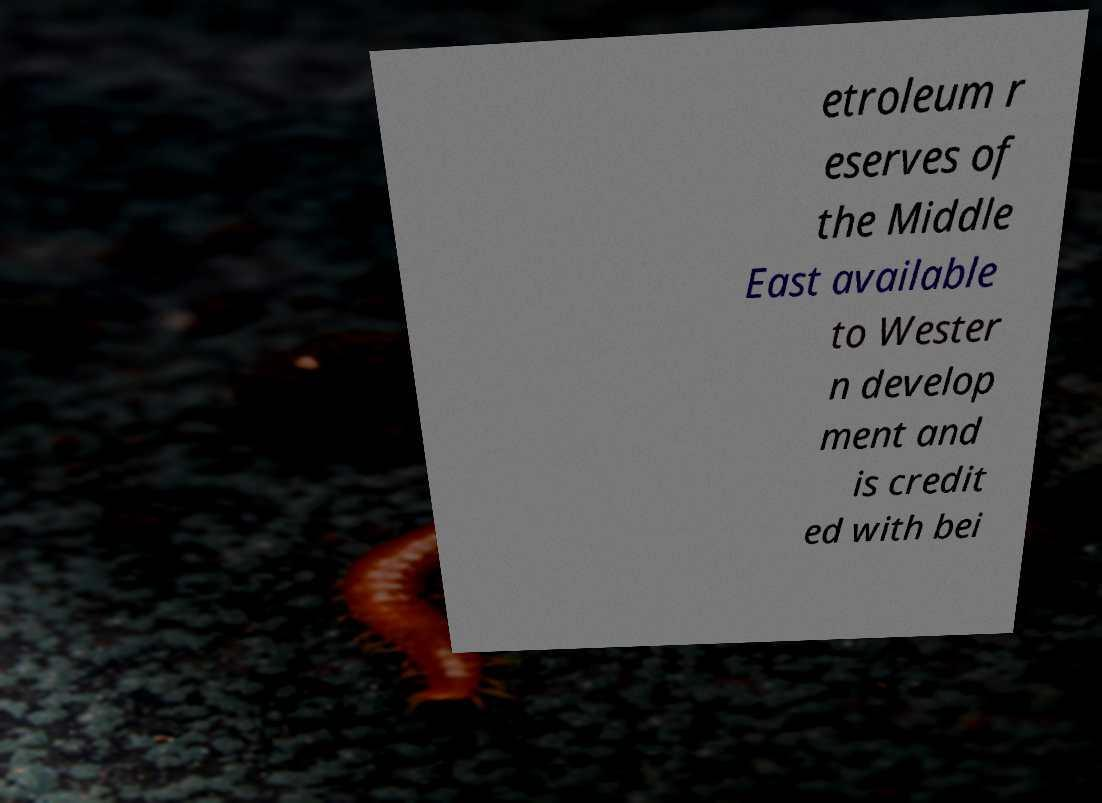Could you extract and type out the text from this image? etroleum r eserves of the Middle East available to Wester n develop ment and is credit ed with bei 